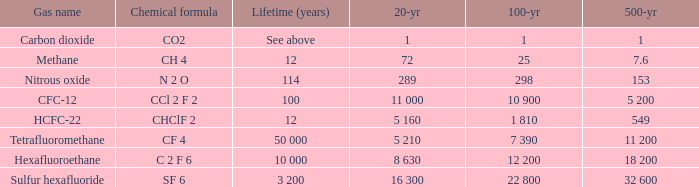What is the lifetime (years) for chemical formula ch 4? 12.0. 